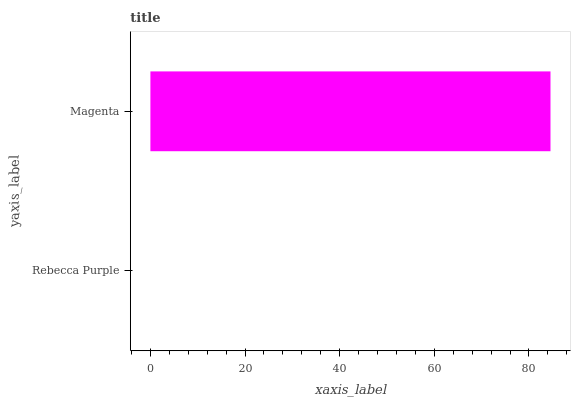Is Rebecca Purple the minimum?
Answer yes or no. Yes. Is Magenta the maximum?
Answer yes or no. Yes. Is Magenta the minimum?
Answer yes or no. No. Is Magenta greater than Rebecca Purple?
Answer yes or no. Yes. Is Rebecca Purple less than Magenta?
Answer yes or no. Yes. Is Rebecca Purple greater than Magenta?
Answer yes or no. No. Is Magenta less than Rebecca Purple?
Answer yes or no. No. Is Magenta the high median?
Answer yes or no. Yes. Is Rebecca Purple the low median?
Answer yes or no. Yes. Is Rebecca Purple the high median?
Answer yes or no. No. Is Magenta the low median?
Answer yes or no. No. 